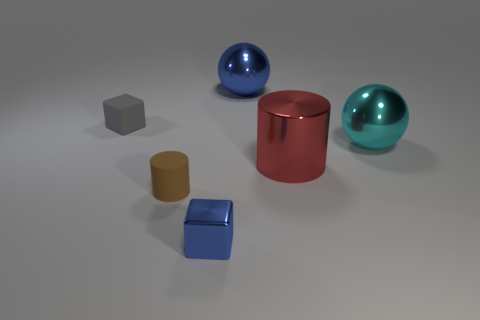There is a small brown object; is it the same shape as the blue metal thing in front of the cyan object? The small brown object appears to be a rectangular cuboid, while the blue metal thing in front has a cylindrical shape. Therefore, they are not the same shape; one has a rectangular face while the other is circular. 